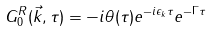Convert formula to latex. <formula><loc_0><loc_0><loc_500><loc_500>G ^ { R } _ { 0 } ( \vec { k } , \tau ) = - i \theta ( \tau ) e ^ { - i \epsilon _ { k } \tau } e ^ { - \Gamma \tau }</formula> 